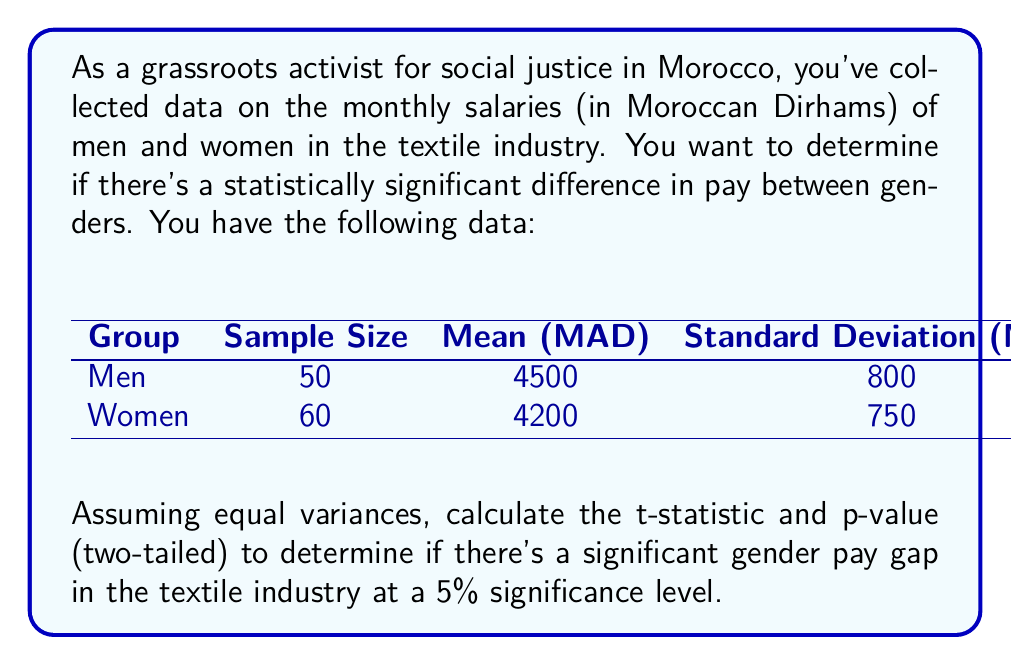Solve this math problem. To determine if there's a statistically significant difference in pay between genders, we'll use an independent samples t-test. Here's the step-by-step process:

1. Calculate the pooled standard deviation:
   $$s_p = \sqrt{\frac{(n_1 - 1)s_1^2 + (n_2 - 1)s_2^2}{n_1 + n_2 - 2}}$$
   
   Where $n_1 = 50$, $n_2 = 60$, $s_1 = 800$, and $s_2 = 750$
   
   $$s_p = \sqrt{\frac{(50 - 1)(800)^2 + (60 - 1)(750)^2}{50 + 60 - 2}} = 773.32$$

2. Calculate the t-statistic:
   $$t = \frac{\bar{X_1} - \bar{X_2}}{s_p\sqrt{\frac{1}{n_1} + \frac{1}{n_2}}}$$
   
   Where $\bar{X_1} = 4500$ and $\bar{X_2} = 4200$
   
   $$t = \frac{4500 - 4200}{773.32\sqrt{\frac{1}{50} + \frac{1}{60}}} = 2.11$$

3. Calculate the degrees of freedom:
   $df = n_1 + n_2 - 2 = 50 + 60 - 2 = 108$

4. Find the p-value:
   Using a t-distribution table or calculator with 108 degrees of freedom and a t-value of 2.11, we get:
   $p-value = 2 * P(T > 2.11) \approx 0.0372$ (two-tailed test)

5. Compare the p-value to the significance level:
   Since $0.0372 < 0.05$, we reject the null hypothesis.
Answer: The t-statistic is 2.11 and the p-value is approximately 0.0372. Since the p-value is less than the significance level of 0.05, we conclude that there is a statistically significant difference in pay between men and women in the textile industry in Morocco. 